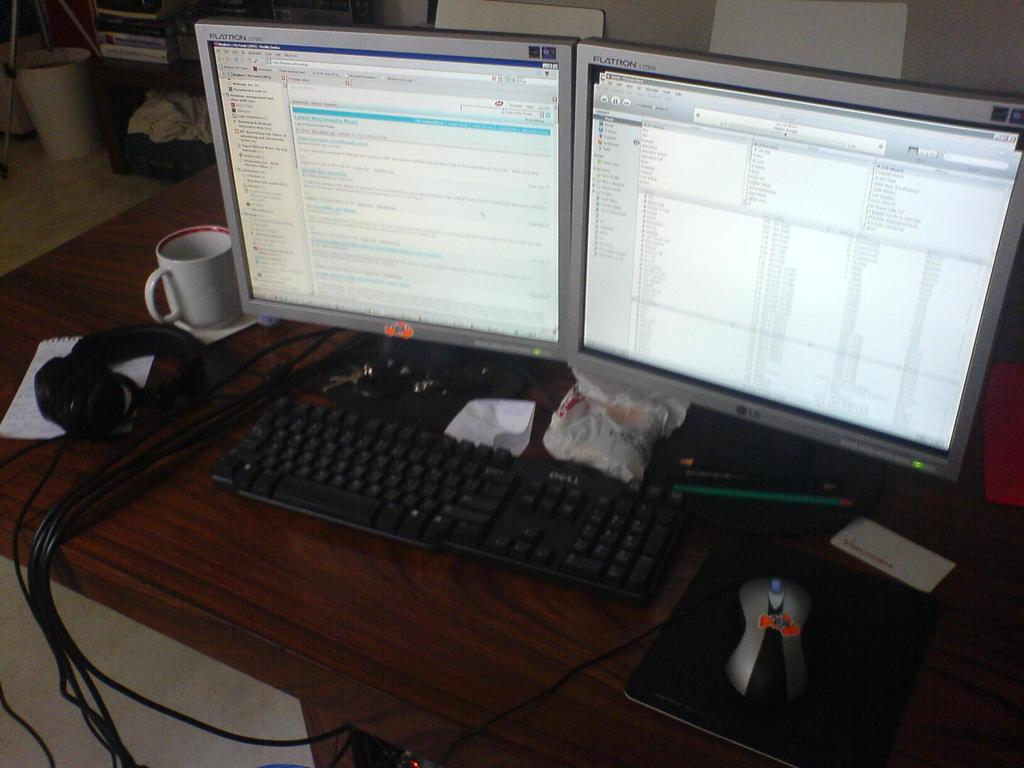<image>
Give a short and clear explanation of the subsequent image. Two Flatron computer monitors are side by side on a desk. 